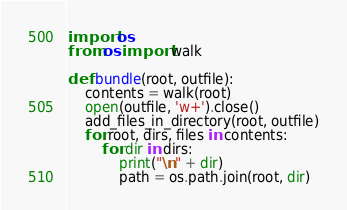Convert code to text. <code><loc_0><loc_0><loc_500><loc_500><_Python_>import os
from os import walk

def bundle(root, outfile):
    contents = walk(root)
    open(outfile, 'w+').close()
    add_files_in_directory(root, outfile)
    for root, dirs, files in contents:
        for dir in dirs:
            print("\n" + dir)
            path = os.path.join(root, dir)</code> 